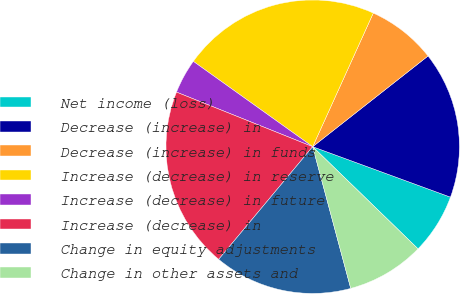<chart> <loc_0><loc_0><loc_500><loc_500><pie_chart><fcel>Net income (loss)<fcel>Decrease (increase) in<fcel>Decrease (increase) in funds<fcel>Increase (decrease) in reserve<fcel>Increase (decrease) in future<fcel>Increase (decrease) in<fcel>Change in equity adjustments<fcel>Change in other assets and<nl><fcel>6.67%<fcel>16.19%<fcel>7.62%<fcel>21.9%<fcel>3.81%<fcel>20.0%<fcel>15.24%<fcel>8.57%<nl></chart> 